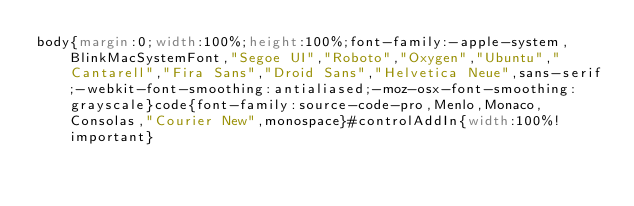<code> <loc_0><loc_0><loc_500><loc_500><_CSS_>body{margin:0;width:100%;height:100%;font-family:-apple-system,BlinkMacSystemFont,"Segoe UI","Roboto","Oxygen","Ubuntu","Cantarell","Fira Sans","Droid Sans","Helvetica Neue",sans-serif;-webkit-font-smoothing:antialiased;-moz-osx-font-smoothing:grayscale}code{font-family:source-code-pro,Menlo,Monaco,Consolas,"Courier New",monospace}#controlAddIn{width:100%!important}</code> 